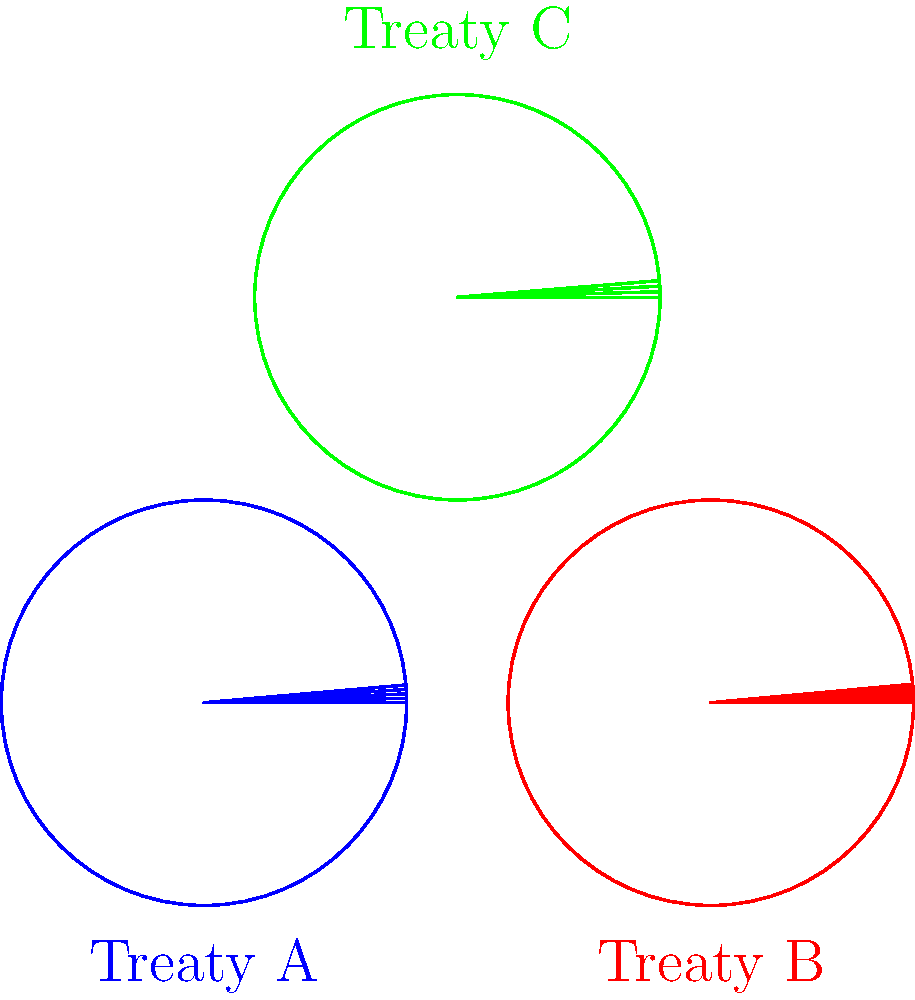Analyze the visual representations of three African Union treaty structures (A, B, and C) shown above. Which treaty has the most comprehensive legal framework based on the number of interconnected sections? To determine which treaty has the most comprehensive legal framework based on the number of interconnected sections, we need to analyze the visual representation of each treaty structure:

1. Treaty A (blue):
   - Has a circular structure with 5 interconnected sections
   - Each section is represented by a line from the center to the circumference

2. Treaty B (red):
   - Has a circular structure with 6 interconnected sections
   - Each section is represented by a line from the center to the circumference

3. Treaty C (green):
   - Has a circular structure with 4 interconnected sections
   - Each section is represented by a line from the center to the circumference

Comparing the number of sections:
- Treaty A: 5 sections
- Treaty B: 6 sections
- Treaty C: 4 sections

Treaty B has the highest number of interconnected sections (6), indicating that it likely has the most comprehensive legal framework among the three treaties represented.
Answer: Treaty B 